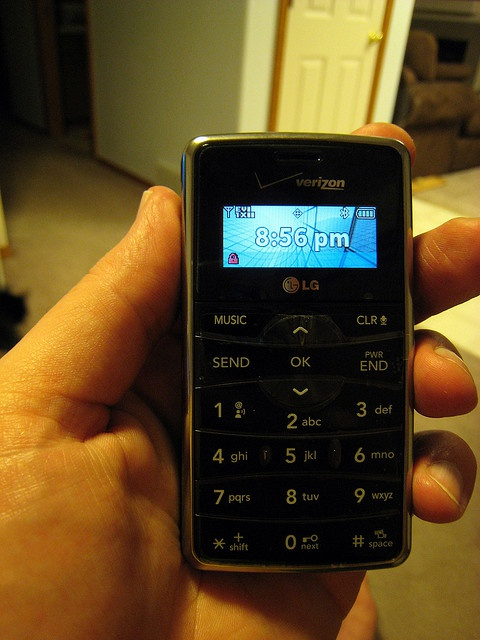Describe the objects in this image and their specific colors. I can see cell phone in black, maroon, olive, and cyan tones and people in black, maroon, red, and orange tones in this image. 